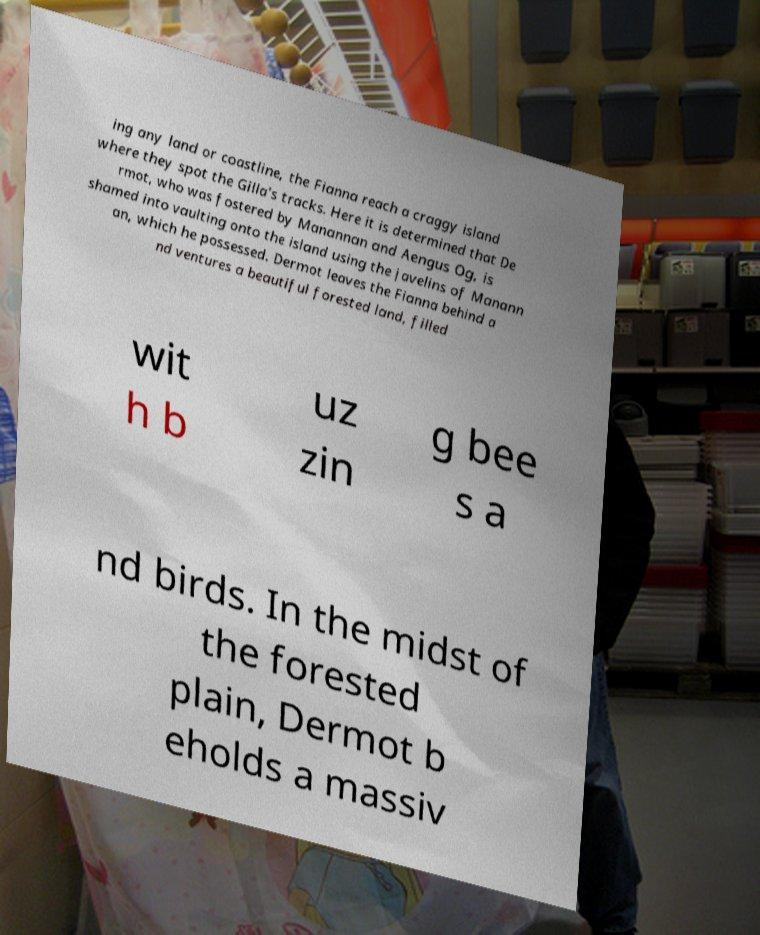Could you extract and type out the text from this image? ing any land or coastline, the Fianna reach a craggy island where they spot the Gilla's tracks. Here it is determined that De rmot, who was fostered by Manannan and Aengus Og, is shamed into vaulting onto the island using the javelins of Manann an, which he possessed. Dermot leaves the Fianna behind a nd ventures a beautiful forested land, filled wit h b uz zin g bee s a nd birds. In the midst of the forested plain, Dermot b eholds a massiv 